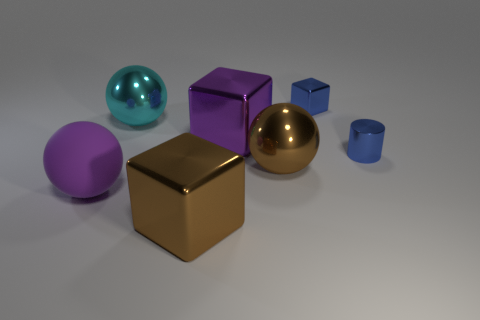Subtract all balls. How many objects are left? 4 Subtract 1 cylinders. How many cylinders are left? 0 Subtract all gray blocks. Subtract all green cylinders. How many blocks are left? 3 Subtract all gray spheres. How many purple cylinders are left? 0 Subtract all big purple objects. Subtract all big brown balls. How many objects are left? 4 Add 7 shiny cubes. How many shiny cubes are left? 10 Add 5 brown blocks. How many brown blocks exist? 6 Add 3 brown objects. How many objects exist? 10 Subtract all brown blocks. How many blocks are left? 2 Subtract all big brown balls. How many balls are left? 2 